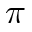<formula> <loc_0><loc_0><loc_500><loc_500>\pi</formula> 